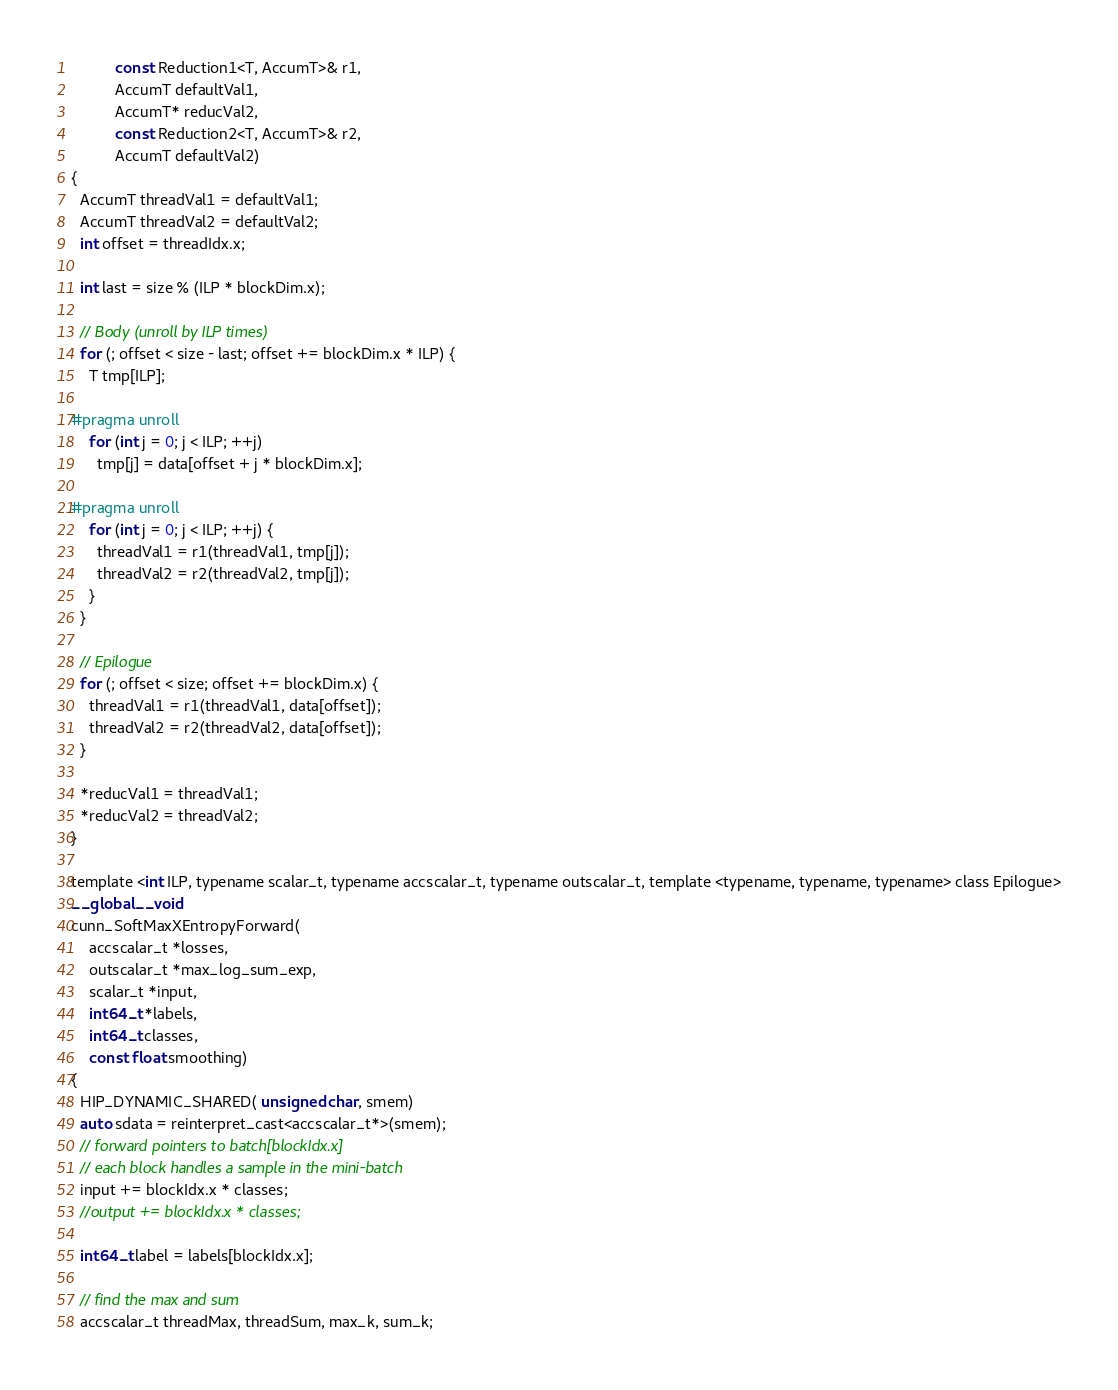Convert code to text. <code><loc_0><loc_0><loc_500><loc_500><_Cuda_>          const Reduction1<T, AccumT>& r1,
          AccumT defaultVal1,
          AccumT* reducVal2,
          const Reduction2<T, AccumT>& r2,
          AccumT defaultVal2)
{
  AccumT threadVal1 = defaultVal1;
  AccumT threadVal2 = defaultVal2;
  int offset = threadIdx.x;

  int last = size % (ILP * blockDim.x);

  // Body (unroll by ILP times)
  for (; offset < size - last; offset += blockDim.x * ILP) {
    T tmp[ILP];

#pragma unroll
    for (int j = 0; j < ILP; ++j)
      tmp[j] = data[offset + j * blockDim.x];

#pragma unroll
    for (int j = 0; j < ILP; ++j) {
      threadVal1 = r1(threadVal1, tmp[j]);
      threadVal2 = r2(threadVal2, tmp[j]);
    }
  }

  // Epilogue
  for (; offset < size; offset += blockDim.x) {
    threadVal1 = r1(threadVal1, data[offset]);
    threadVal2 = r2(threadVal2, data[offset]);
  }

  *reducVal1 = threadVal1;
  *reducVal2 = threadVal2;
}

template <int ILP, typename scalar_t, typename accscalar_t, typename outscalar_t, template <typename, typename, typename> class Epilogue>
__global__ void
cunn_SoftMaxXEntropyForward(
    accscalar_t *losses,
    outscalar_t *max_log_sum_exp,
    scalar_t *input,
    int64_t *labels,
    int64_t classes,
    const float smoothing)
{
  HIP_DYNAMIC_SHARED( unsigned char, smem)
  auto sdata = reinterpret_cast<accscalar_t*>(smem);
  // forward pointers to batch[blockIdx.x]
  // each block handles a sample in the mini-batch
  input += blockIdx.x * classes;
  //output += blockIdx.x * classes;

  int64_t label = labels[blockIdx.x];

  // find the max and sum
  accscalar_t threadMax, threadSum, max_k, sum_k;</code> 